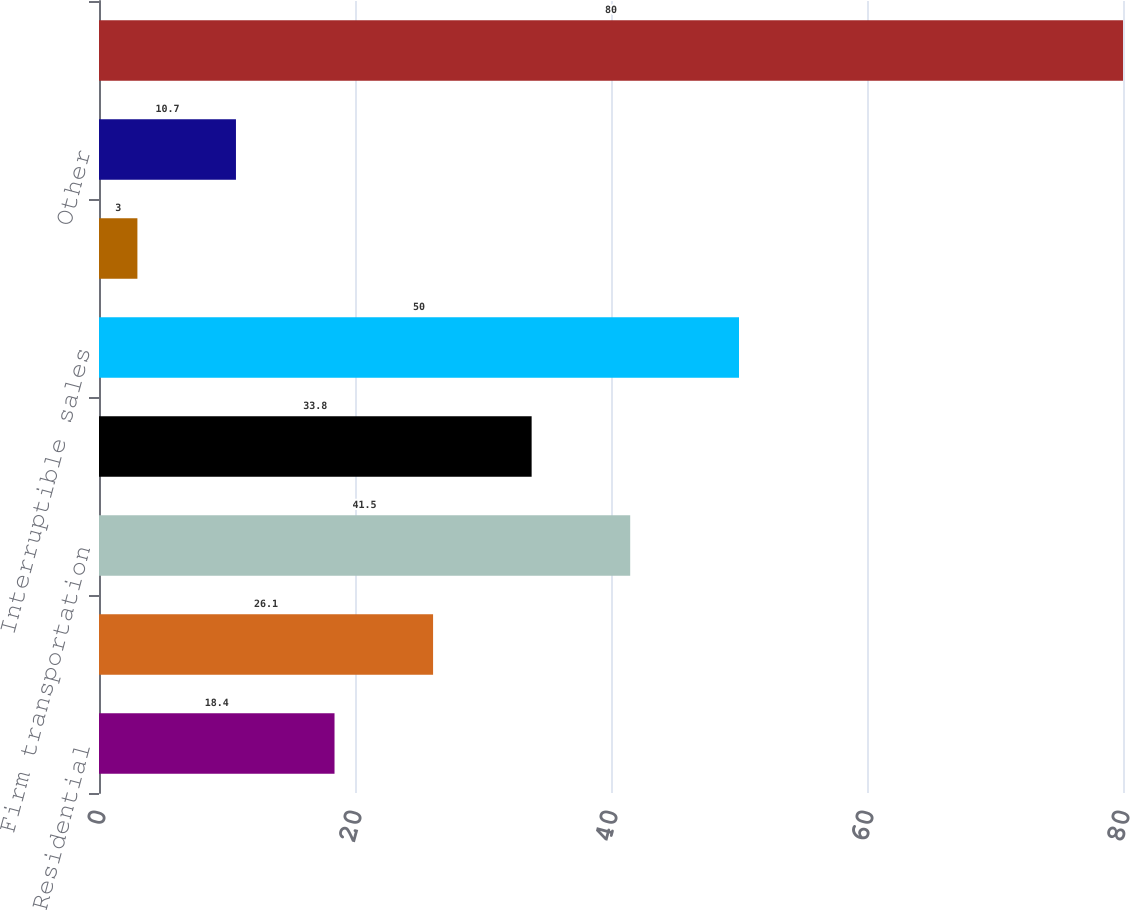Convert chart. <chart><loc_0><loc_0><loc_500><loc_500><bar_chart><fcel>Residential<fcel>General<fcel>Firm transportation<fcel>Total firm sales and<fcel>Interruptible sales<fcel>Generation plants<fcel>Other<fcel>Total<nl><fcel>18.4<fcel>26.1<fcel>41.5<fcel>33.8<fcel>50<fcel>3<fcel>10.7<fcel>80<nl></chart> 